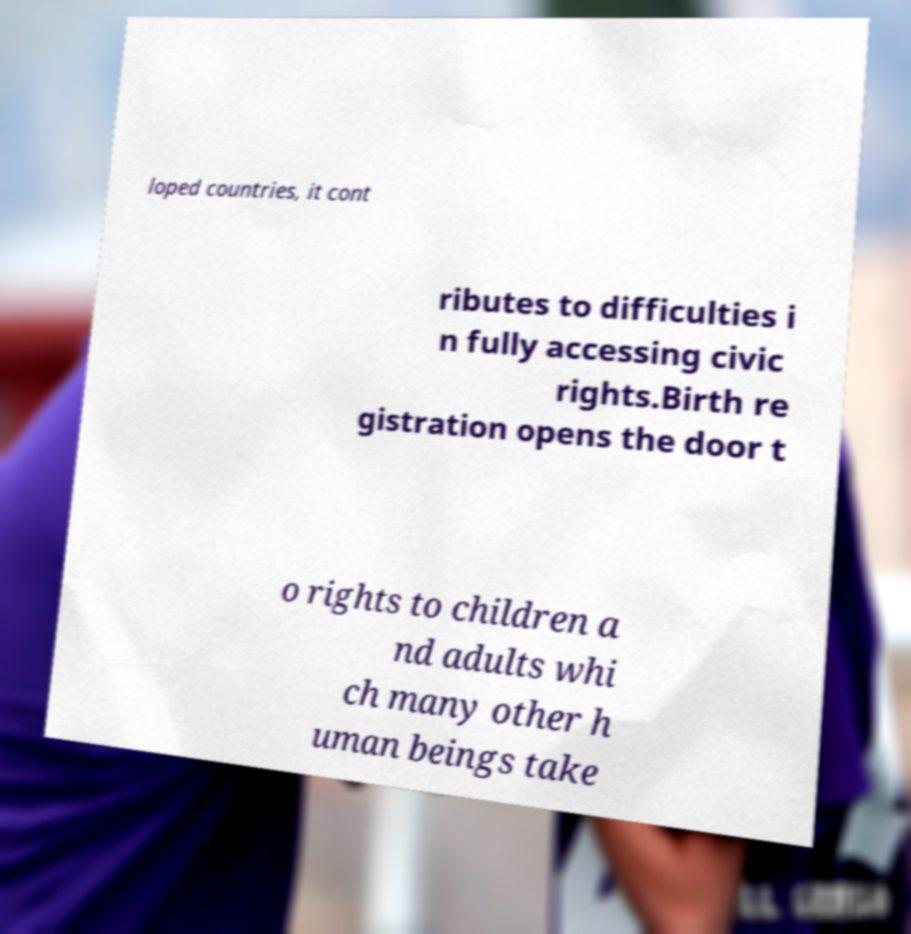Can you accurately transcribe the text from the provided image for me? loped countries, it cont ributes to difficulties i n fully accessing civic rights.Birth re gistration opens the door t o rights to children a nd adults whi ch many other h uman beings take 